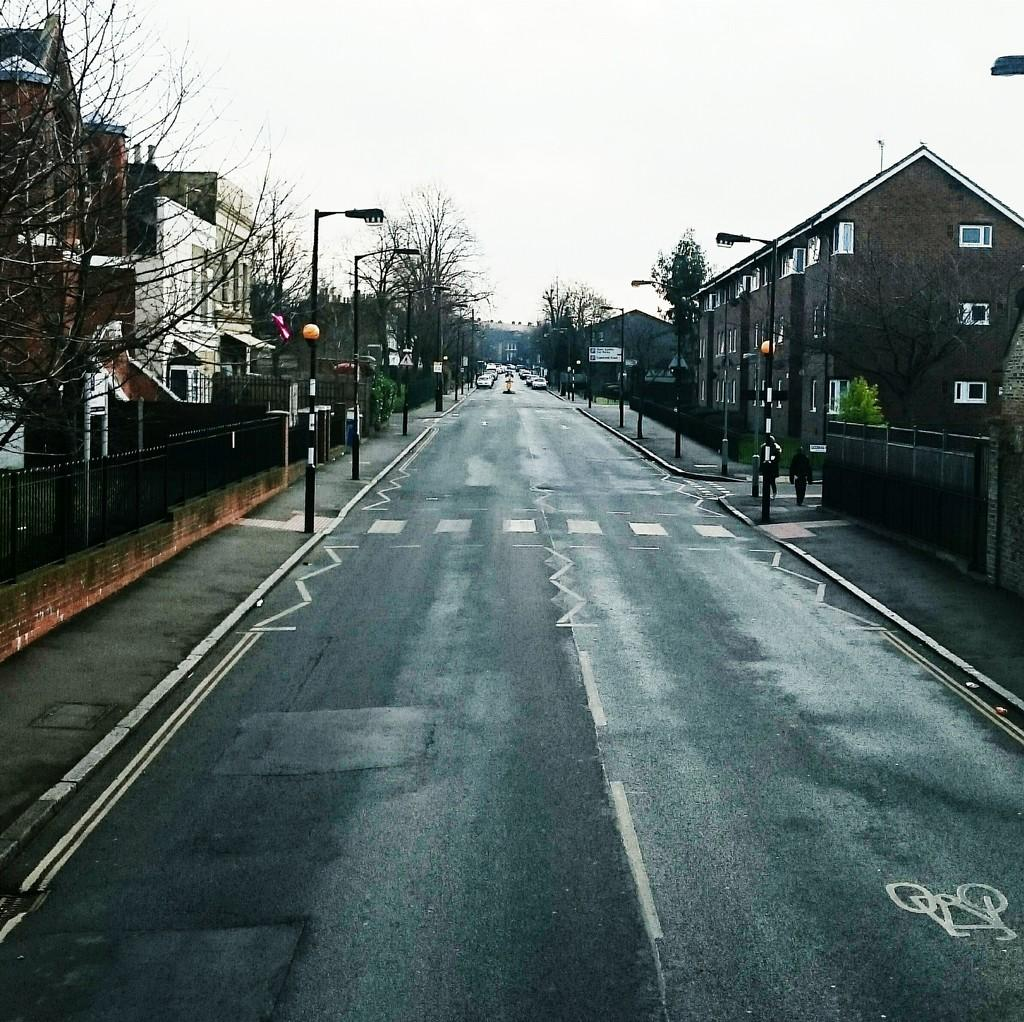What type of vehicles can be seen on the road in the image? There are cars on the road in the image. What structures are present on both sides of the road? There are poles and trees on both sides of the road. What type of buildings can be seen on both sides of the road? Houses are visible on both sides of the road. What is visible at the top of the image? The sky is visible at the top of the image. Can you see the impulse of the cars on the road in the image? There is no mention of an impulse in the image, and it is not a visible characteristic of the cars or the road. --- Facts: 1. There is a person holding a book in the image. 2. The person is sitting on a chair. 3. There is a table next to the chair. 4. The table has a lamp on it. 5. The background of the image is a room. Absurd Topics: parrot, trampoline, ocean Conversation: What is the person in the image holding? The person in the image is holding a book. What is the person's position in the image? The person is sitting on a chair. What is next to the chair? There is a table next to the chair. What is on the table? The table has a lamp on it. What can be seen in the background of the image? The background of the image is a room. Reasoning: Let's think step by step in order to produce the conversation. We start by identifying the main subject in the image, which is the person holding a book. Then, we expand the conversation to include other elements that are also visible, such as the chair, table, lamp, and room. Each question is designed to elicit a specific detail about the image that is known from the provided facts. Absurd Question/Answer: Can you see a parrot on the trampoline in the ocean in the image? There is no mention of a parrot, trampoline, or ocean in the image. The image shows a person sitting on a chair, holding a book, with a table and lamp nearby, in a room. 